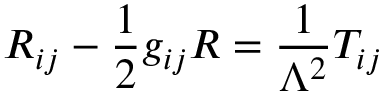<formula> <loc_0><loc_0><loc_500><loc_500>R _ { i j } - { \frac { 1 } { 2 } } g _ { i j } R = { \frac { 1 } { \Lambda ^ { 2 } } } T _ { i j }</formula> 